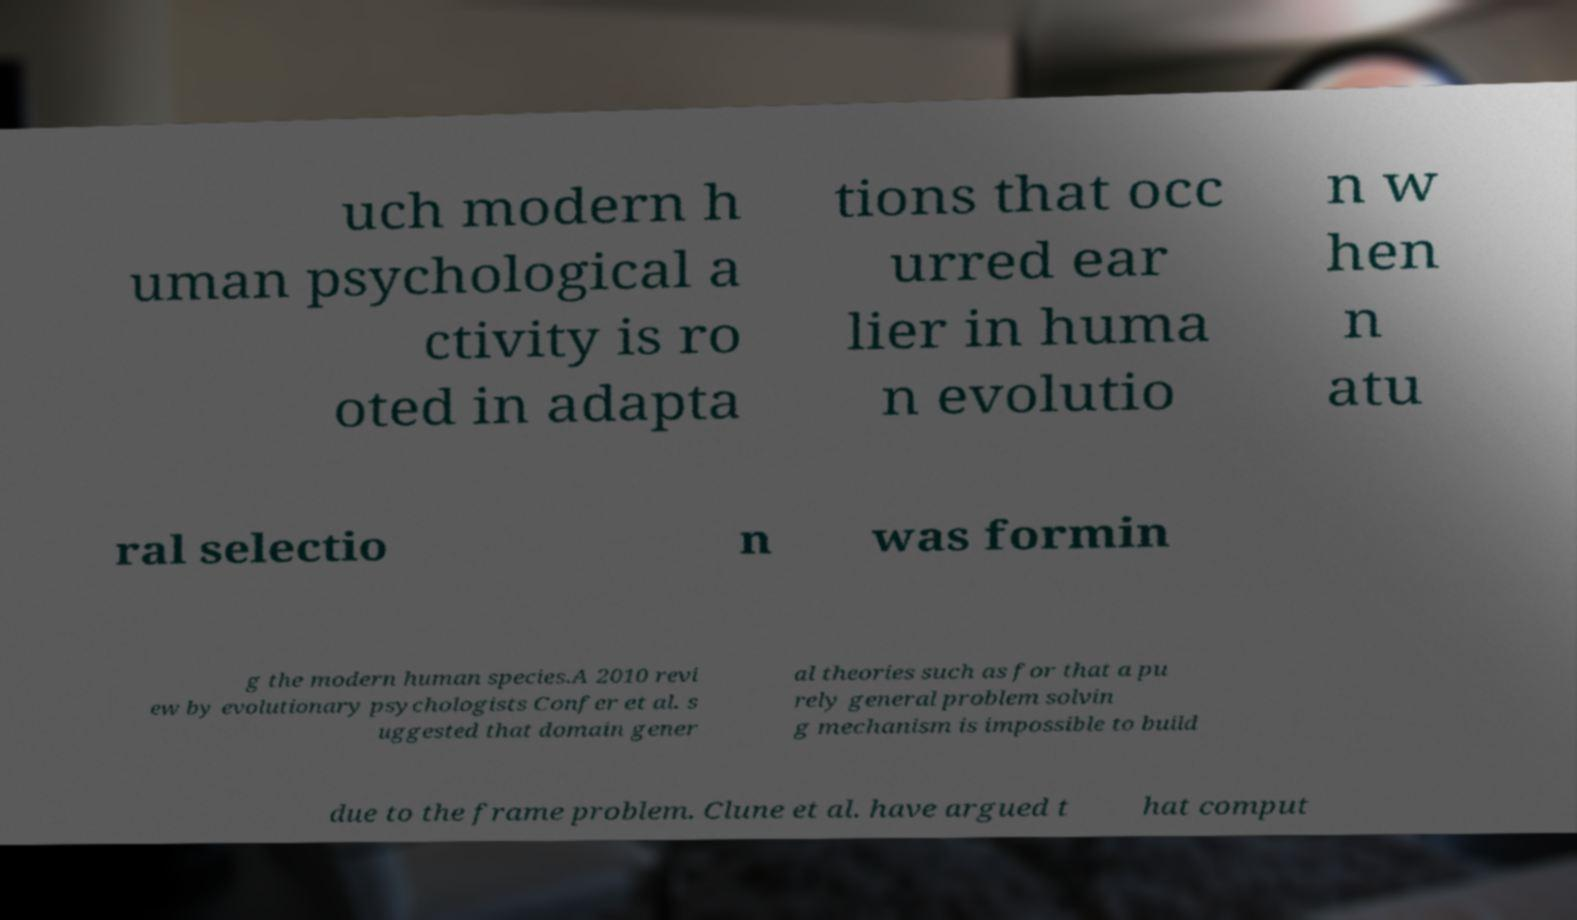Could you extract and type out the text from this image? uch modern h uman psychological a ctivity is ro oted in adapta tions that occ urred ear lier in huma n evolutio n w hen n atu ral selectio n was formin g the modern human species.A 2010 revi ew by evolutionary psychologists Confer et al. s uggested that domain gener al theories such as for that a pu rely general problem solvin g mechanism is impossible to build due to the frame problem. Clune et al. have argued t hat comput 